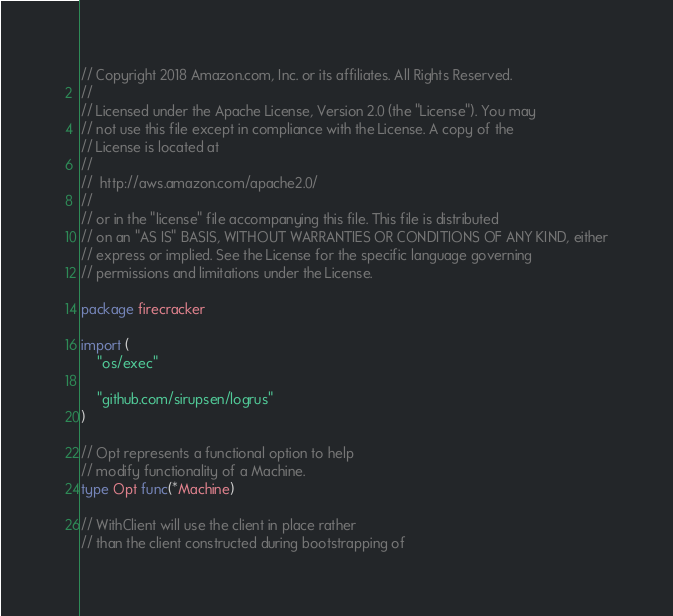Convert code to text. <code><loc_0><loc_0><loc_500><loc_500><_Go_>// Copyright 2018 Amazon.com, Inc. or its affiliates. All Rights Reserved.
//
// Licensed under the Apache License, Version 2.0 (the "License"). You may
// not use this file except in compliance with the License. A copy of the
// License is located at
//
//	http://aws.amazon.com/apache2.0/
//
// or in the "license" file accompanying this file. This file is distributed
// on an "AS IS" BASIS, WITHOUT WARRANTIES OR CONDITIONS OF ANY KIND, either
// express or implied. See the License for the specific language governing
// permissions and limitations under the License.

package firecracker

import (
	"os/exec"

	"github.com/sirupsen/logrus"
)

// Opt represents a functional option to help
// modify functionality of a Machine.
type Opt func(*Machine)

// WithClient will use the client in place rather
// than the client constructed during bootstrapping of</code> 